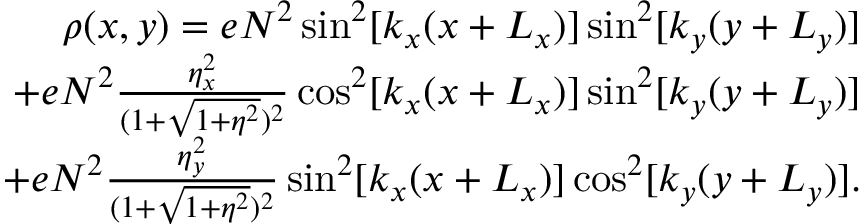Convert formula to latex. <formula><loc_0><loc_0><loc_500><loc_500>\begin{array} { r l r } & { \rho ( x , y ) = e N ^ { 2 } \sin ^ { 2 } [ k _ { x } ( x + L _ { x } ) ] \sin ^ { 2 } [ k _ { y } ( y + L _ { y } ) ] } \\ & { + e N ^ { 2 } \frac { \eta _ { x } ^ { 2 } } { ( 1 + \sqrt { 1 + \eta ^ { 2 } } ) ^ { 2 } } \cos ^ { 2 } [ k _ { x } ( x + L _ { x } ) ] \sin ^ { 2 } [ k _ { y } ( y + L _ { y } ) ] } \\ & { + e N ^ { 2 } \frac { \eta _ { y } ^ { 2 } } { ( 1 + \sqrt { 1 + \eta ^ { 2 } } ) ^ { 2 } } \sin ^ { 2 } [ k _ { x } ( x + L _ { x } ) ] \cos ^ { 2 } [ k _ { y } ( y + L _ { y } ) ] . } \end{array}</formula> 